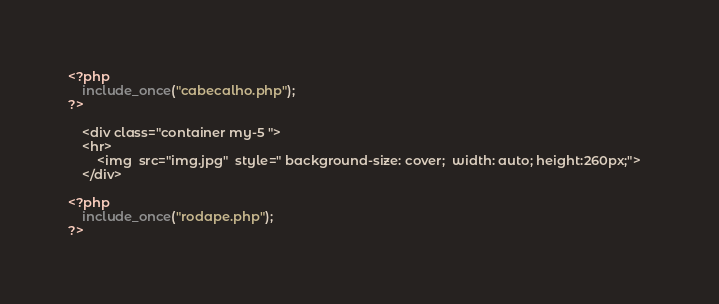<code> <loc_0><loc_0><loc_500><loc_500><_PHP_><?php 
	include_once("cabecalho.php"); 
?>
   
    <div class="container my-5 ">
    <hr>	
		<img  src="img.jpg"  style=" background-size: cover;  width: auto; height:260px;">	
    </div>
    
<?php 
	include_once("rodape.php");
?></code> 